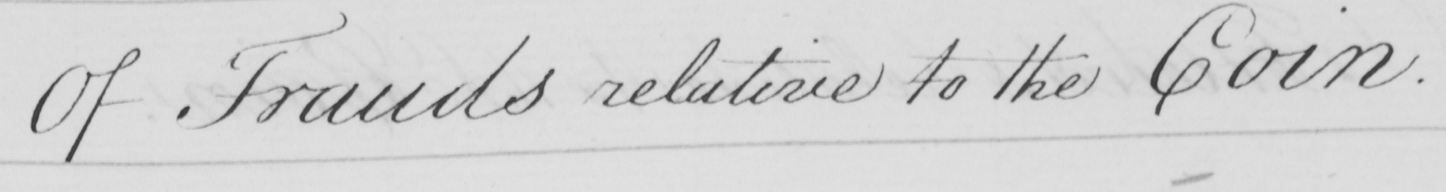Transcribe the text shown in this historical manuscript line. Of Frauds relative to the Coin . 